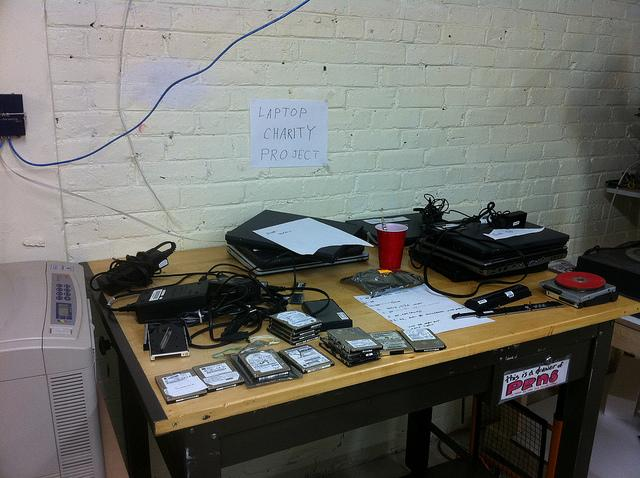What is likely the most valuable object shown? laptop 